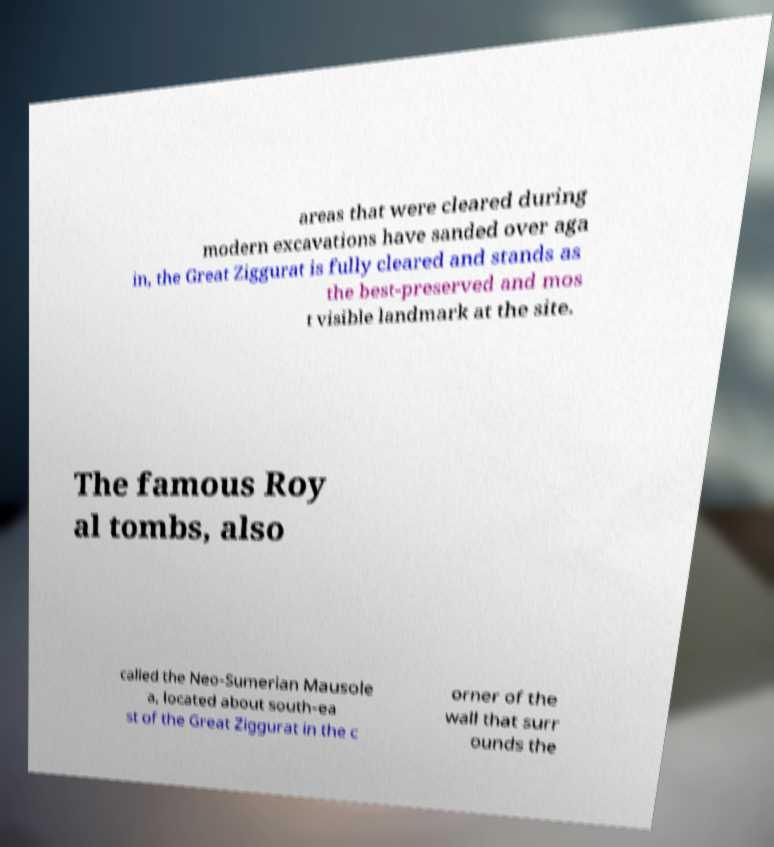Could you assist in decoding the text presented in this image and type it out clearly? areas that were cleared during modern excavations have sanded over aga in, the Great Ziggurat is fully cleared and stands as the best-preserved and mos t visible landmark at the site. The famous Roy al tombs, also called the Neo-Sumerian Mausole a, located about south-ea st of the Great Ziggurat in the c orner of the wall that surr ounds the 